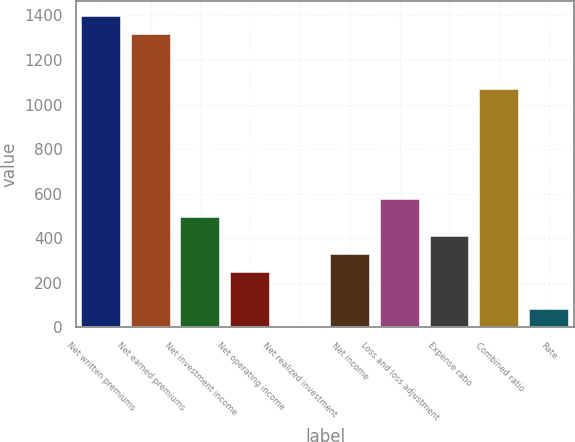Convert chart to OTSL. <chart><loc_0><loc_0><loc_500><loc_500><bar_chart><fcel>Net written premiums<fcel>Net earned premiums<fcel>Net investment income<fcel>Net operating income<fcel>Net realized investment<fcel>Net income<fcel>Loss and loss adjustment<fcel>Expense ratio<fcel>Combined ratio<fcel>Rate<nl><fcel>1396.7<fcel>1314.6<fcel>493.6<fcel>247.3<fcel>1<fcel>329.4<fcel>575.7<fcel>411.5<fcel>1068.3<fcel>83.1<nl></chart> 